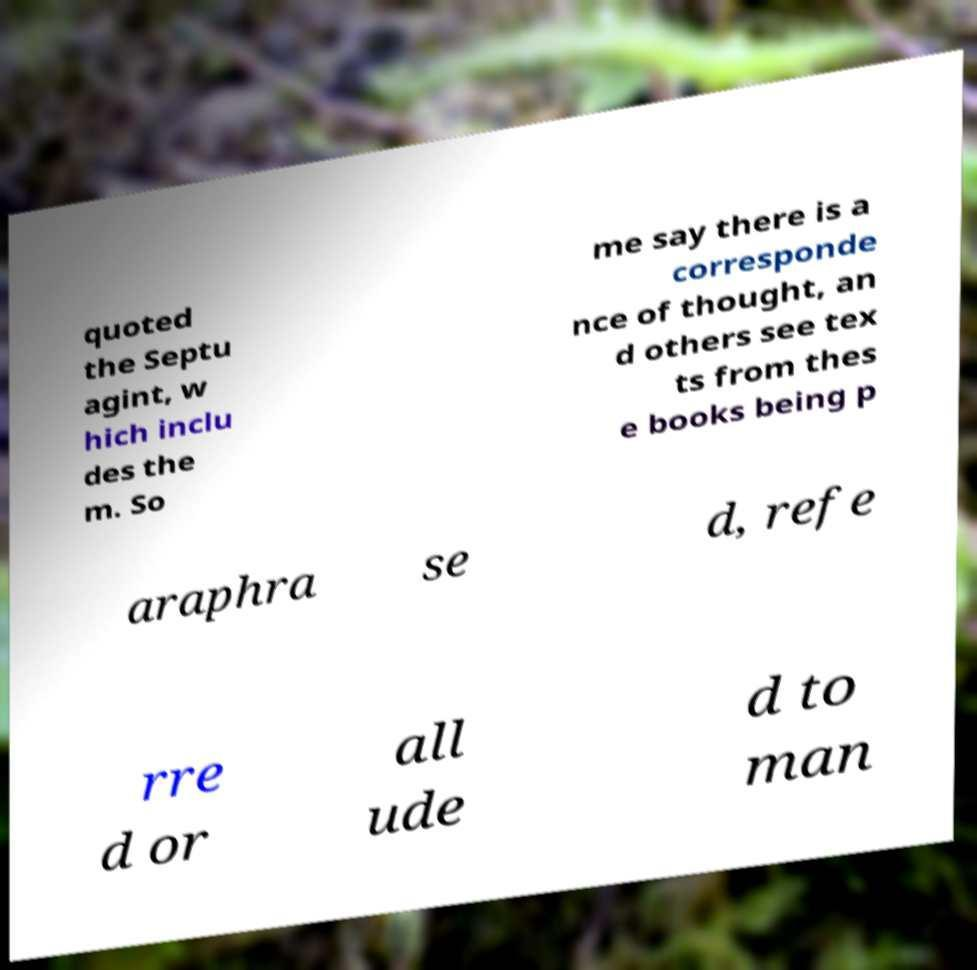Please identify and transcribe the text found in this image. quoted the Septu agint, w hich inclu des the m. So me say there is a corresponde nce of thought, an d others see tex ts from thes e books being p araphra se d, refe rre d or all ude d to man 